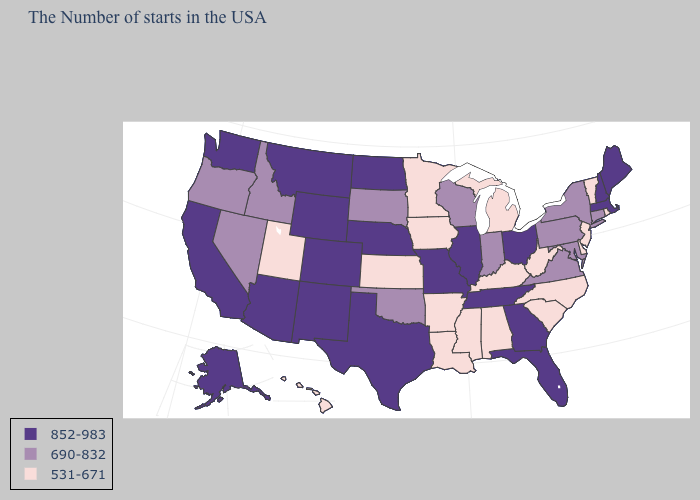Does Michigan have the highest value in the USA?
Give a very brief answer. No. Which states hav the highest value in the West?
Write a very short answer. Wyoming, Colorado, New Mexico, Montana, Arizona, California, Washington, Alaska. Name the states that have a value in the range 852-983?
Short answer required. Maine, Massachusetts, New Hampshire, Ohio, Florida, Georgia, Tennessee, Illinois, Missouri, Nebraska, Texas, North Dakota, Wyoming, Colorado, New Mexico, Montana, Arizona, California, Washington, Alaska. Name the states that have a value in the range 690-832?
Give a very brief answer. Connecticut, New York, Maryland, Pennsylvania, Virginia, Indiana, Wisconsin, Oklahoma, South Dakota, Idaho, Nevada, Oregon. Does the map have missing data?
Answer briefly. No. Does New Hampshire have the highest value in the Northeast?
Write a very short answer. Yes. Name the states that have a value in the range 852-983?
Keep it brief. Maine, Massachusetts, New Hampshire, Ohio, Florida, Georgia, Tennessee, Illinois, Missouri, Nebraska, Texas, North Dakota, Wyoming, Colorado, New Mexico, Montana, Arizona, California, Washington, Alaska. Name the states that have a value in the range 531-671?
Give a very brief answer. Rhode Island, Vermont, New Jersey, Delaware, North Carolina, South Carolina, West Virginia, Michigan, Kentucky, Alabama, Mississippi, Louisiana, Arkansas, Minnesota, Iowa, Kansas, Utah, Hawaii. What is the value of Nebraska?
Keep it brief. 852-983. What is the value of Colorado?
Write a very short answer. 852-983. Is the legend a continuous bar?
Answer briefly. No. Among the states that border Georgia , does Florida have the highest value?
Be succinct. Yes. What is the value of Alaska?
Write a very short answer. 852-983. What is the highest value in the West ?
Concise answer only. 852-983. Does Ohio have the same value as Alabama?
Short answer required. No. 